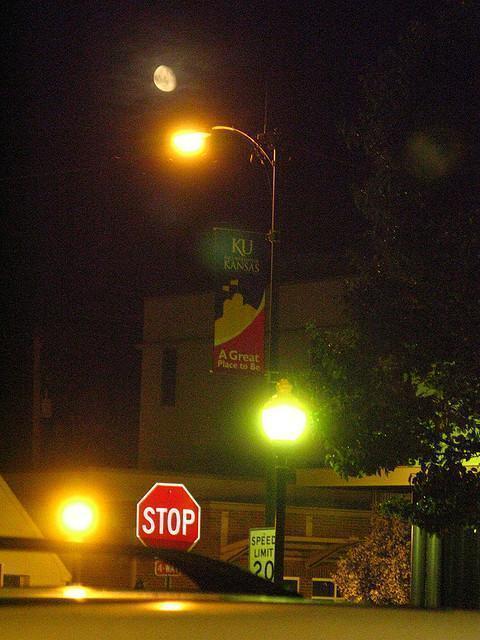How many lights are shining bright on the side of the campus street?
Select the correct answer and articulate reasoning with the following format: 'Answer: answer
Rationale: rationale.'
Options: Six, one, two, three. Answer: three.
Rationale: One light is in between two other lights. 